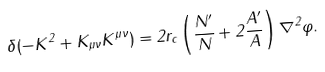Convert formula to latex. <formula><loc_0><loc_0><loc_500><loc_500>\delta ( - K ^ { 2 } + K _ { \mu \nu } K ^ { \mu \nu } ) = 2 r _ { c } \left ( \frac { N ^ { \prime } } { N } + 2 \frac { A ^ { \prime } } { A } \right ) \nabla ^ { 2 } \varphi .</formula> 